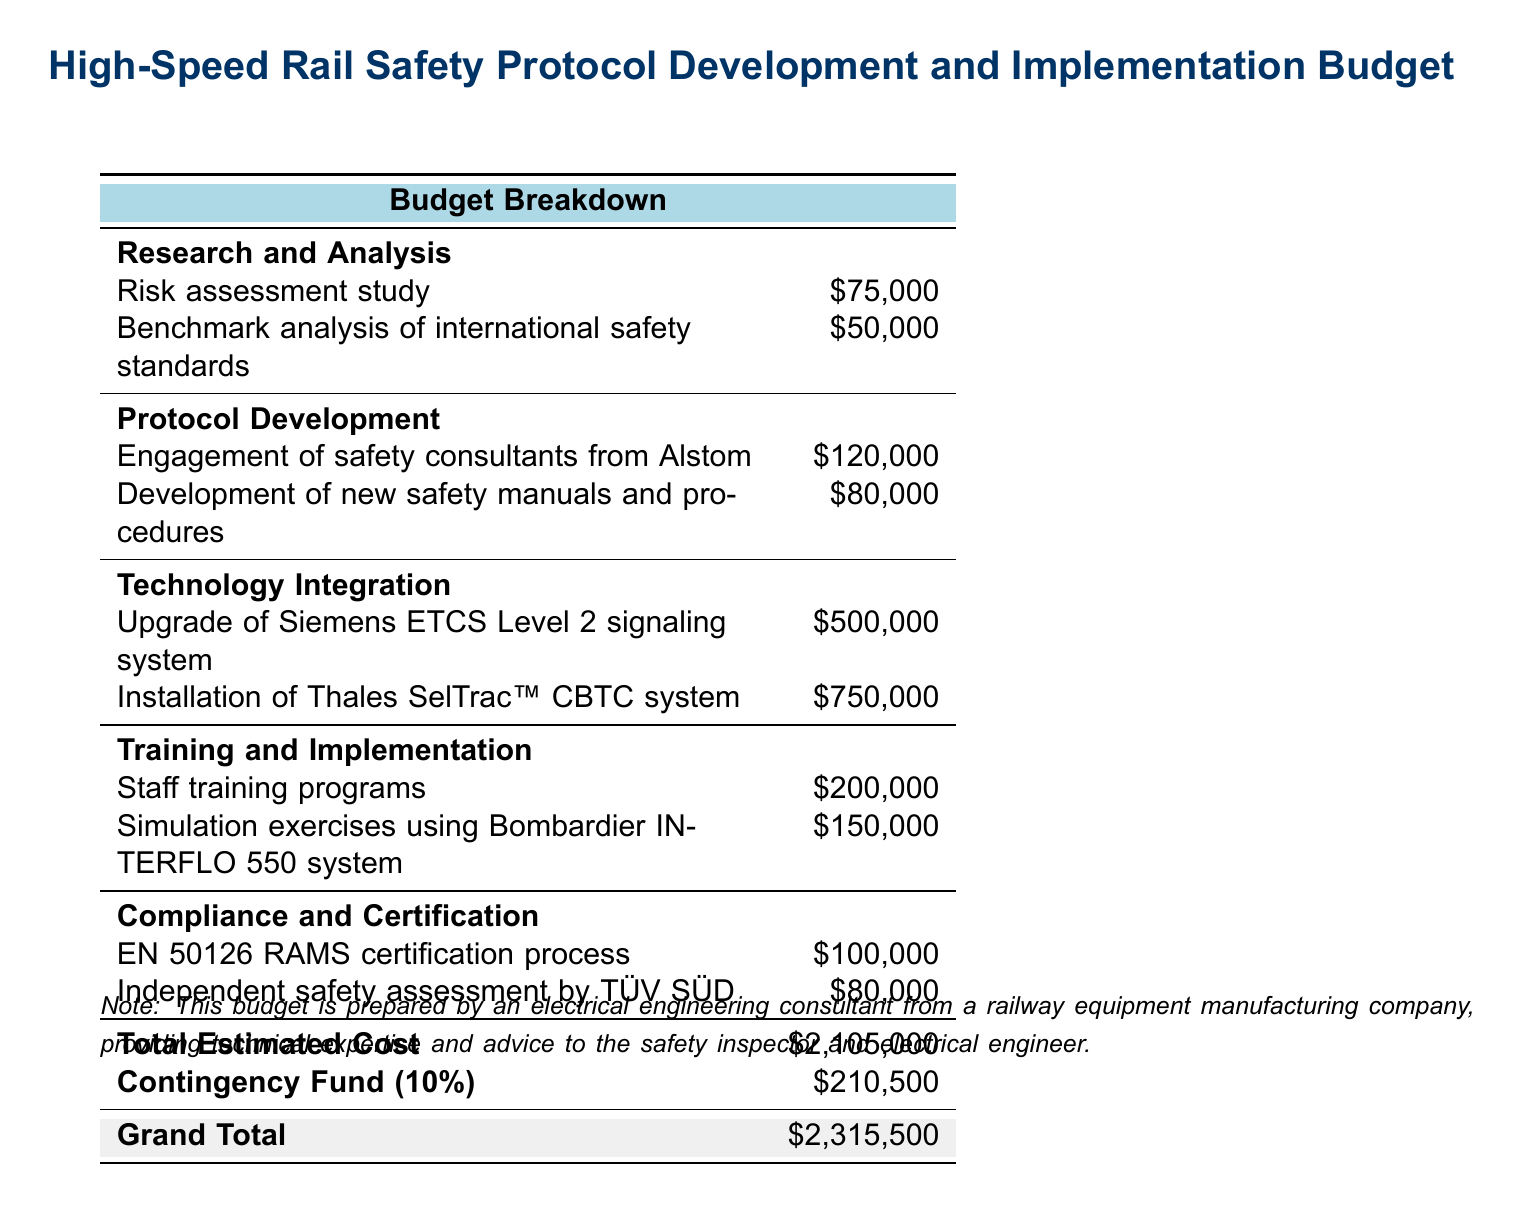What is the total estimated cost? The total estimated cost is clearly listed in the document and is the sum of all the budgeted items.
Answer: $2,105,000 What is the budget allocated for technology integration? The budget for technology integration includes two items: upgrade of Siemens ETCS Level 2 signaling system and installation of Thales SelTrac™ CBTC system, both of which total a specific amount.
Answer: $1,250,000 How much is allocated for staff training programs? The cost for staff training programs is specified in the training and implementation section of the budget.
Answer: $200,000 What is the total amount set aside for the contingency fund? The contingency fund is calculated as a percentage of the total estimated cost and is explicitly mentioned in the document.
Answer: $210,500 What is the cost for the independent safety assessment by TÜV SÜD? The cost for the independent safety assessment is listed under compliance and certification.
Answer: $80,000 Which organization is engaged for safety consultation? The document specifies a particular organization responsible for consulting services in safety.
Answer: Alstom What is the cost associated with the development of new safety manuals and procedures? The budget clearly identifies the cost allocated for the development of new safety manuals and procedures under protocol development.
Answer: $80,000 How much is the budget for the EN 50126 RAMS certification process? The budget specifies the cost for the EN 50126 RAMS certification process in its compliance section.
Answer: $100,000 What is the grand total of the budget after including the contingency fund? The grand total is calculated by adding the total estimated cost and the contingency fund, thus is explicitly presented at the end of the document.
Answer: $2,315,500 